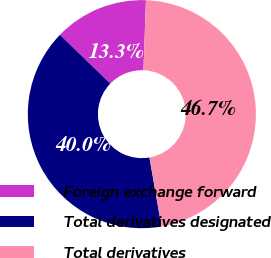Convert chart. <chart><loc_0><loc_0><loc_500><loc_500><pie_chart><fcel>Foreign exchange forward<fcel>Total derivatives designated<fcel>Total derivatives<nl><fcel>13.33%<fcel>40.0%<fcel>46.67%<nl></chart> 